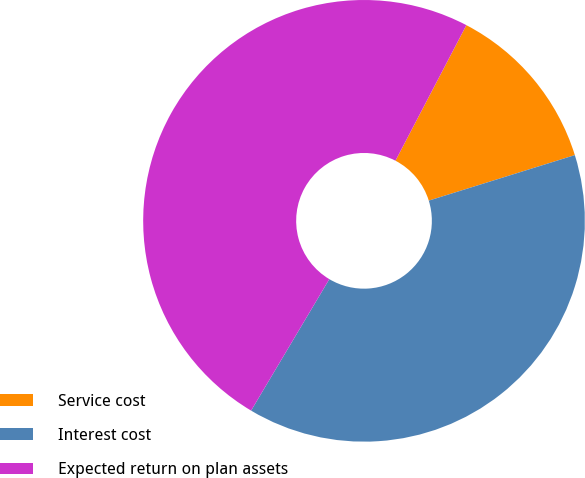Convert chart to OTSL. <chart><loc_0><loc_0><loc_500><loc_500><pie_chart><fcel>Service cost<fcel>Interest cost<fcel>Expected return on plan assets<nl><fcel>12.52%<fcel>38.35%<fcel>49.13%<nl></chart> 